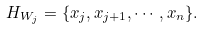<formula> <loc_0><loc_0><loc_500><loc_500>H _ { W _ { j } } = \{ x _ { j } , x _ { j + 1 } , \cdots , x _ { n } \} .</formula> 